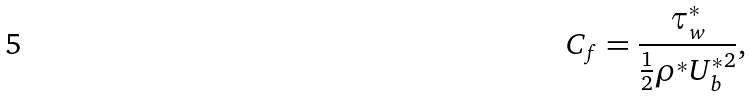Convert formula to latex. <formula><loc_0><loc_0><loc_500><loc_500>C _ { f } = \frac { \tau ^ { * } _ { w } } { \frac { 1 } { 2 } \rho ^ { * } { U ^ { * } _ { b } } ^ { 2 } } ,</formula> 